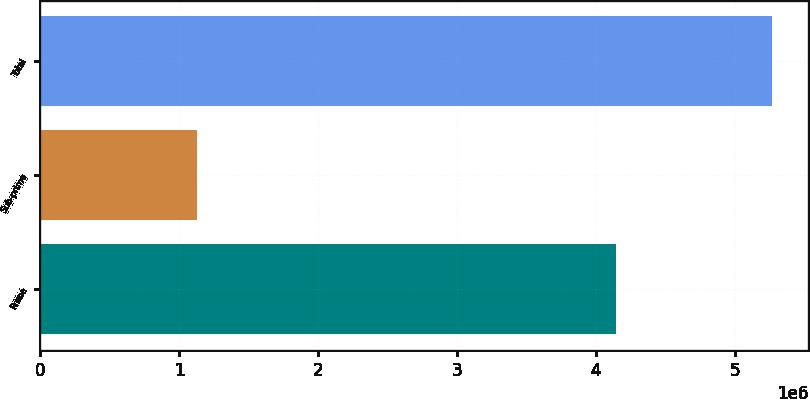Convert chart to OTSL. <chart><loc_0><loc_0><loc_500><loc_500><bar_chart><fcel>Prime<fcel>Sub-prime<fcel>Total<nl><fcel>4.14156e+06<fcel>1.12348e+06<fcel>5.26504e+06<nl></chart> 